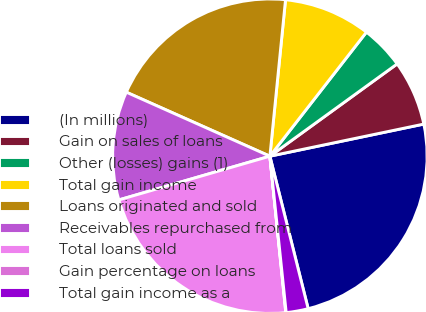Convert chart. <chart><loc_0><loc_0><loc_500><loc_500><pie_chart><fcel>(In millions)<fcel>Gain on sales of loans<fcel>Other (losses) gains (1)<fcel>Total gain income<fcel>Loans originated and sold<fcel>Receivables repurchased from<fcel>Total loans sold<fcel>Gain percentage on loans<fcel>Total gain income as a<nl><fcel>24.36%<fcel>6.71%<fcel>4.49%<fcel>8.94%<fcel>19.91%<fcel>11.16%<fcel>22.13%<fcel>0.04%<fcel>2.26%<nl></chart> 